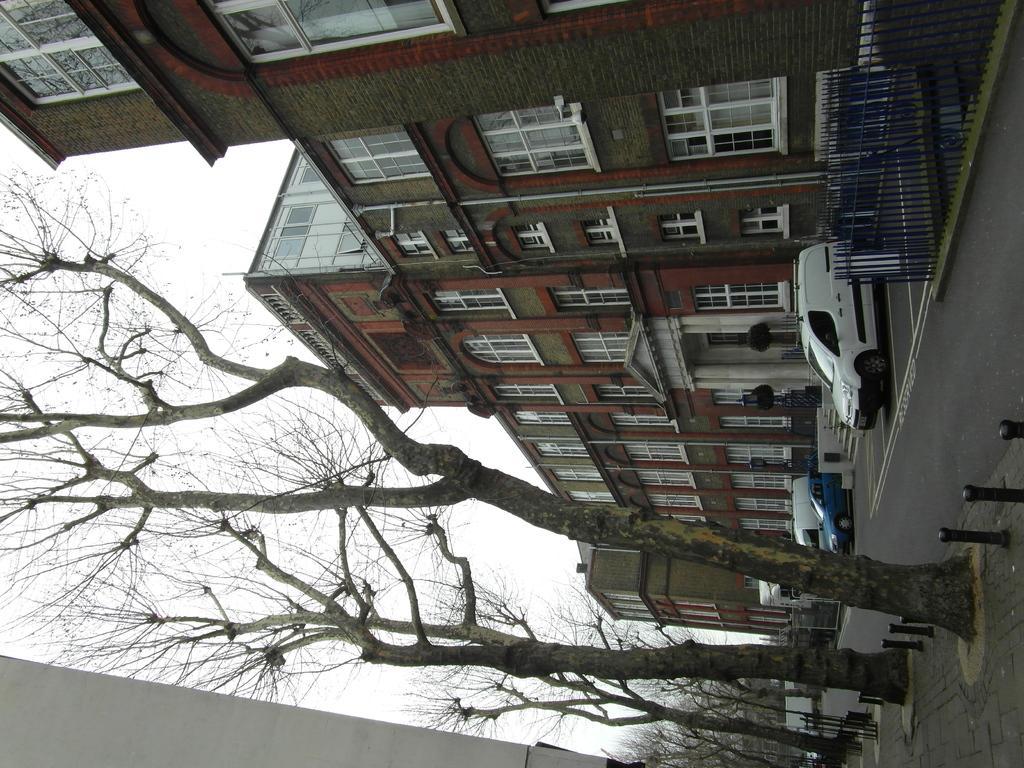How would you summarize this image in a sentence or two? In this image there are buildings, railing and some vehicles, plants and there are some roads, trees, pavement. And in the background there is sky. 